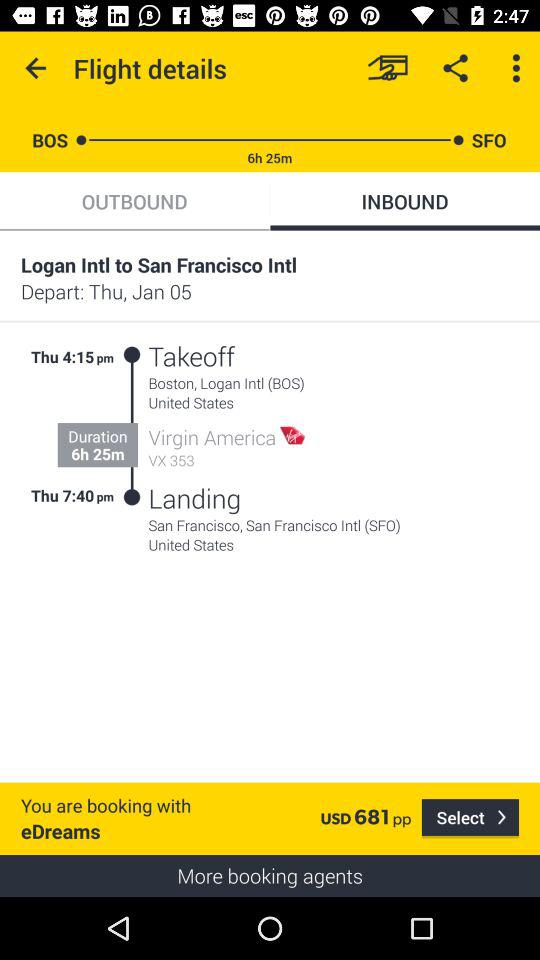What is the total duration of the flight?
Answer the question using a single word or phrase. 6h 25m 